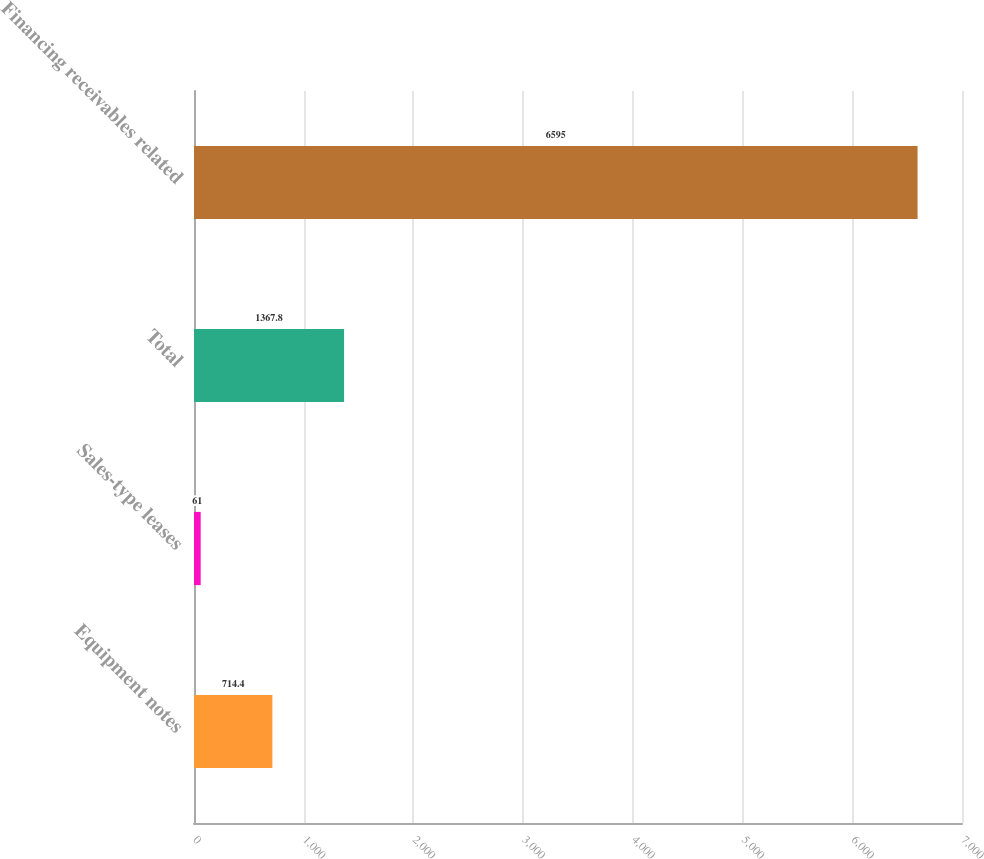Convert chart. <chart><loc_0><loc_0><loc_500><loc_500><bar_chart><fcel>Equipment notes<fcel>Sales-type leases<fcel>Total<fcel>Financing receivables related<nl><fcel>714.4<fcel>61<fcel>1367.8<fcel>6595<nl></chart> 